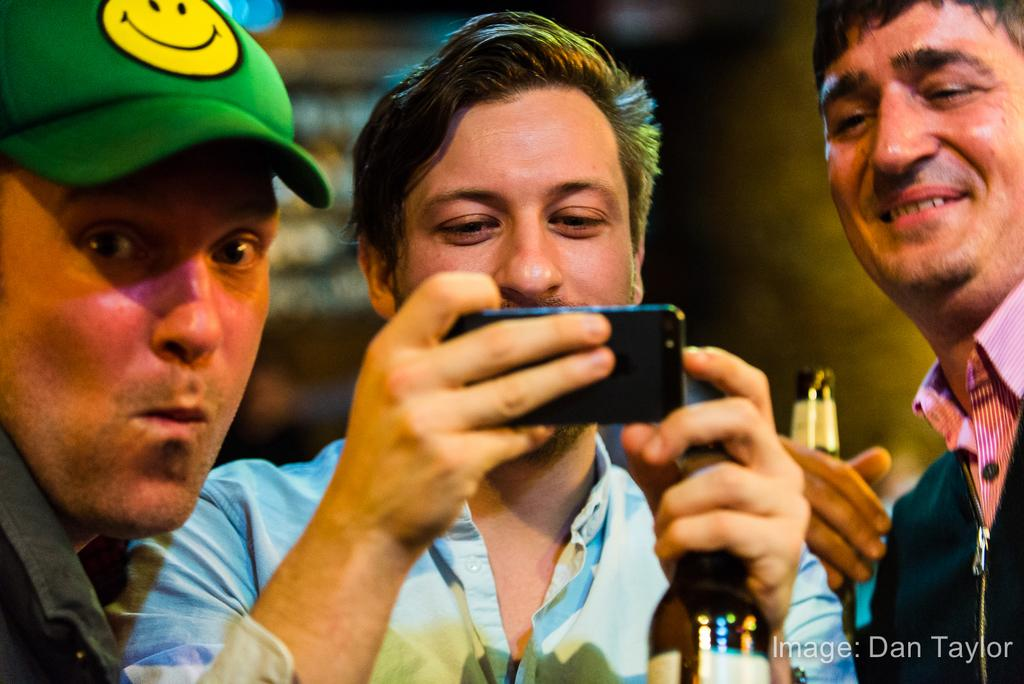How many people are in the image? There are three persons in the image. What are the three persons doing in the image? The three persons are standing together. What is one person doing specifically? One person is catching a phone. How many legs can be seen in the image? The provided facts do not mention the number of legs visible in the image, so it cannot be determined from the information given. 